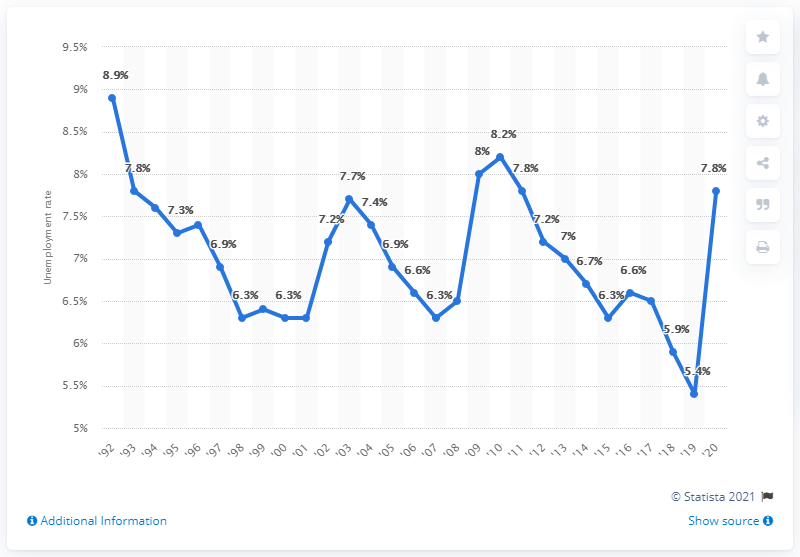Compared to the overall trend, how does Alaska's unemployment rate in 2010 stand out? In 2010, Alaska's unemployment rate exhibited a peak value, aligning with the national and worldwide economic circumstances of the time. The rate was around 7.8%, which is significantly higher than the preceding and succeeding years, indicating a period of economic distress that may reflect the aftermath of the 2008 financial crisis. 